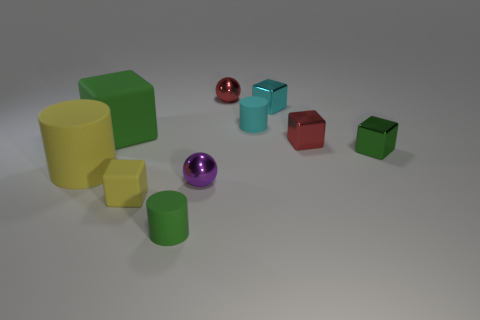There is a large green rubber cube; are there any tiny green metallic things behind it?
Give a very brief answer. No. Do the purple shiny object and the green rubber cylinder have the same size?
Offer a terse response. Yes. There is a green rubber thing behind the purple ball; what shape is it?
Provide a short and direct response. Cube. Are there any balls that have the same size as the cyan block?
Offer a very short reply. Yes. What material is the cyan block that is the same size as the red metallic cube?
Offer a terse response. Metal. There is a cylinder that is behind the large yellow rubber cylinder; what size is it?
Your answer should be very brief. Small. The cyan cube is what size?
Make the answer very short. Small. Do the cyan rubber object and the green rubber object that is in front of the purple thing have the same size?
Provide a succinct answer. Yes. The tiny sphere that is behind the metallic block that is on the left side of the red cube is what color?
Keep it short and to the point. Red. Are there the same number of small green things right of the tiny cyan shiny block and big green rubber things that are in front of the small purple object?
Provide a short and direct response. No. 